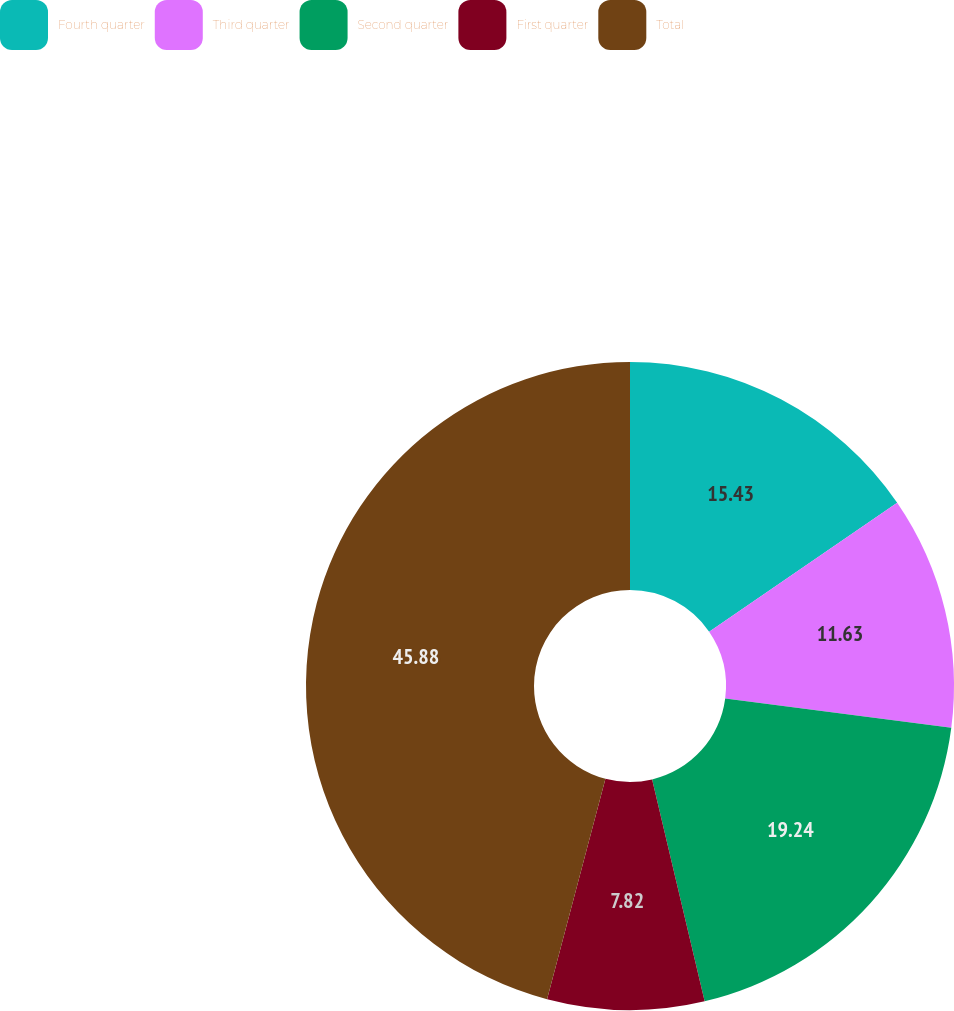Convert chart to OTSL. <chart><loc_0><loc_0><loc_500><loc_500><pie_chart><fcel>Fourth quarter<fcel>Third quarter<fcel>Second quarter<fcel>First quarter<fcel>Total<nl><fcel>15.43%<fcel>11.63%<fcel>19.24%<fcel>7.82%<fcel>45.88%<nl></chart> 